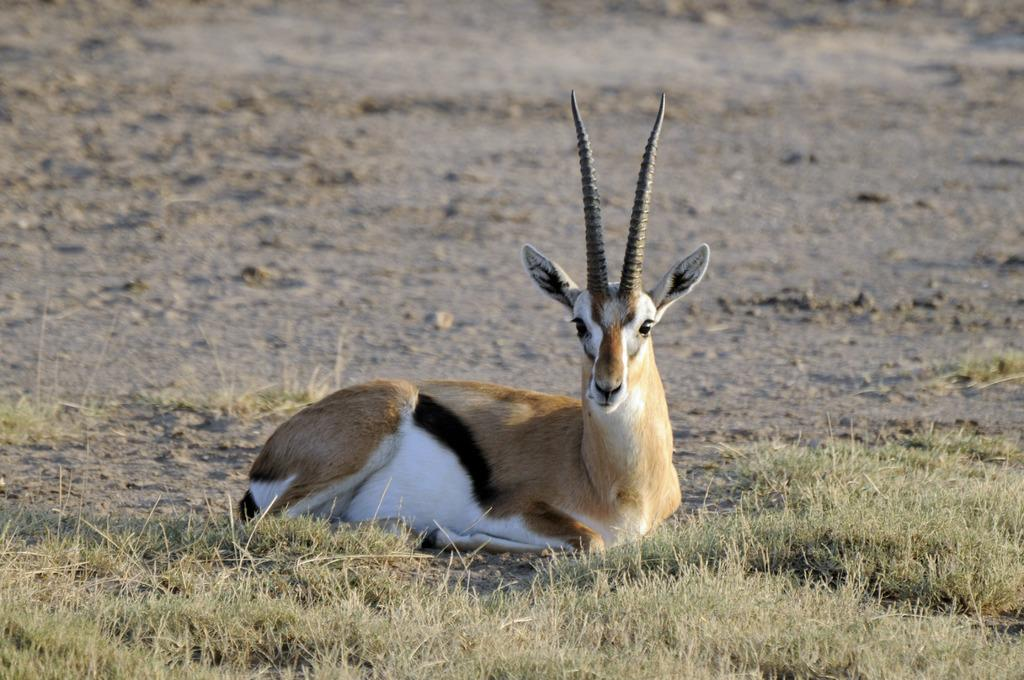What animal is present in the image? There is a deer in the image. What is the deer doing in the image? The deer is sitting on the land. What type of terrain is visible at the bottom of the image? The bottom of the image contains grassy land. What can be seen in the background of the image? The background of the image includes land with soil. Where is the playground located in the image? There is no playground present in the image; it features a deer sitting on the land. What type of map is visible in the image? There is no map present in the image; it features a deer sitting on the land. 